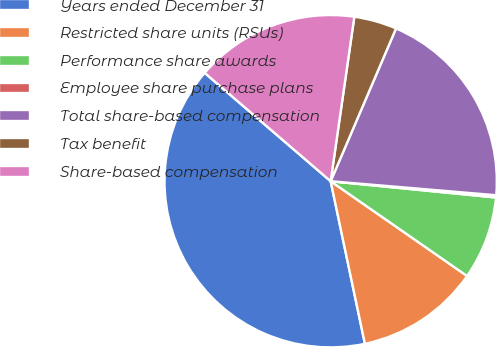Convert chart. <chart><loc_0><loc_0><loc_500><loc_500><pie_chart><fcel>Years ended December 31<fcel>Restricted share units (RSUs)<fcel>Performance share awards<fcel>Employee share purchase plans<fcel>Total share-based compensation<fcel>Tax benefit<fcel>Share-based compensation<nl><fcel>39.61%<fcel>12.03%<fcel>8.1%<fcel>0.22%<fcel>19.91%<fcel>4.16%<fcel>15.97%<nl></chart> 